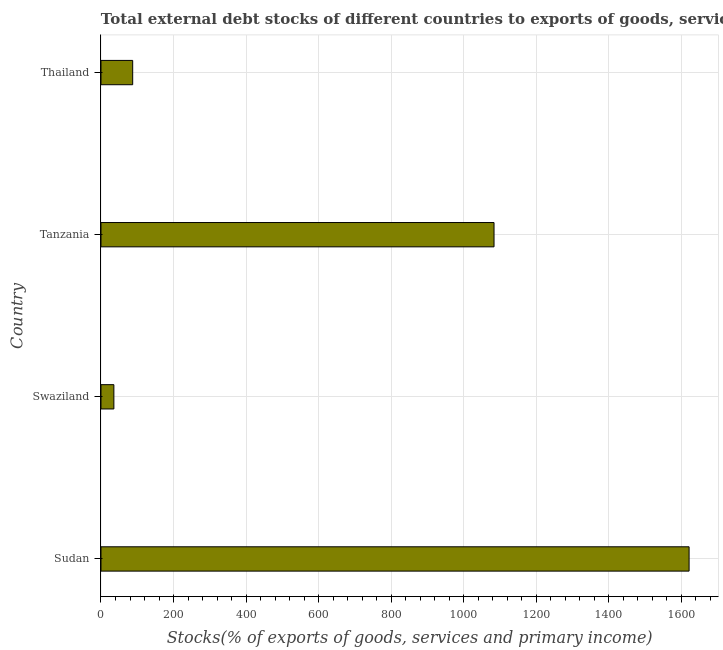Does the graph contain any zero values?
Provide a succinct answer. No. Does the graph contain grids?
Keep it short and to the point. Yes. What is the title of the graph?
Your response must be concise. Total external debt stocks of different countries to exports of goods, services and primary income in 1989. What is the label or title of the X-axis?
Keep it short and to the point. Stocks(% of exports of goods, services and primary income). What is the label or title of the Y-axis?
Ensure brevity in your answer.  Country. What is the external debt stocks in Thailand?
Offer a very short reply. 87.39. Across all countries, what is the maximum external debt stocks?
Offer a terse response. 1621.22. Across all countries, what is the minimum external debt stocks?
Provide a succinct answer. 35.51. In which country was the external debt stocks maximum?
Keep it short and to the point. Sudan. In which country was the external debt stocks minimum?
Give a very brief answer. Swaziland. What is the sum of the external debt stocks?
Keep it short and to the point. 2827.6. What is the difference between the external debt stocks in Sudan and Tanzania?
Give a very brief answer. 537.73. What is the average external debt stocks per country?
Ensure brevity in your answer.  706.9. What is the median external debt stocks?
Give a very brief answer. 585.44. What is the ratio of the external debt stocks in Tanzania to that in Thailand?
Provide a short and direct response. 12.4. Is the external debt stocks in Tanzania less than that in Thailand?
Provide a succinct answer. No. Is the difference between the external debt stocks in Sudan and Swaziland greater than the difference between any two countries?
Your response must be concise. Yes. What is the difference between the highest and the second highest external debt stocks?
Offer a very short reply. 537.73. What is the difference between the highest and the lowest external debt stocks?
Make the answer very short. 1585.71. How many bars are there?
Give a very brief answer. 4. What is the difference between two consecutive major ticks on the X-axis?
Offer a terse response. 200. What is the Stocks(% of exports of goods, services and primary income) in Sudan?
Provide a short and direct response. 1621.22. What is the Stocks(% of exports of goods, services and primary income) of Swaziland?
Give a very brief answer. 35.51. What is the Stocks(% of exports of goods, services and primary income) of Tanzania?
Give a very brief answer. 1083.49. What is the Stocks(% of exports of goods, services and primary income) of Thailand?
Your answer should be compact. 87.39. What is the difference between the Stocks(% of exports of goods, services and primary income) in Sudan and Swaziland?
Give a very brief answer. 1585.71. What is the difference between the Stocks(% of exports of goods, services and primary income) in Sudan and Tanzania?
Provide a succinct answer. 537.73. What is the difference between the Stocks(% of exports of goods, services and primary income) in Sudan and Thailand?
Your answer should be very brief. 1533.83. What is the difference between the Stocks(% of exports of goods, services and primary income) in Swaziland and Tanzania?
Your answer should be compact. -1047.98. What is the difference between the Stocks(% of exports of goods, services and primary income) in Swaziland and Thailand?
Keep it short and to the point. -51.88. What is the difference between the Stocks(% of exports of goods, services and primary income) in Tanzania and Thailand?
Your response must be concise. 996.1. What is the ratio of the Stocks(% of exports of goods, services and primary income) in Sudan to that in Swaziland?
Offer a very short reply. 45.66. What is the ratio of the Stocks(% of exports of goods, services and primary income) in Sudan to that in Tanzania?
Make the answer very short. 1.5. What is the ratio of the Stocks(% of exports of goods, services and primary income) in Sudan to that in Thailand?
Provide a succinct answer. 18.55. What is the ratio of the Stocks(% of exports of goods, services and primary income) in Swaziland to that in Tanzania?
Provide a succinct answer. 0.03. What is the ratio of the Stocks(% of exports of goods, services and primary income) in Swaziland to that in Thailand?
Provide a succinct answer. 0.41. What is the ratio of the Stocks(% of exports of goods, services and primary income) in Tanzania to that in Thailand?
Your answer should be compact. 12.4. 